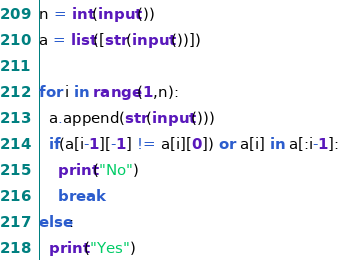<code> <loc_0><loc_0><loc_500><loc_500><_Python_>n = int(input())
a = list([str(input())])

for i in range(1,n):
  a.append(str(input()))
  if(a[i-1][-1] != a[i][0]) or a[i] in a[:i-1]:
    print("No")
    break
else:
  print("Yes")</code> 